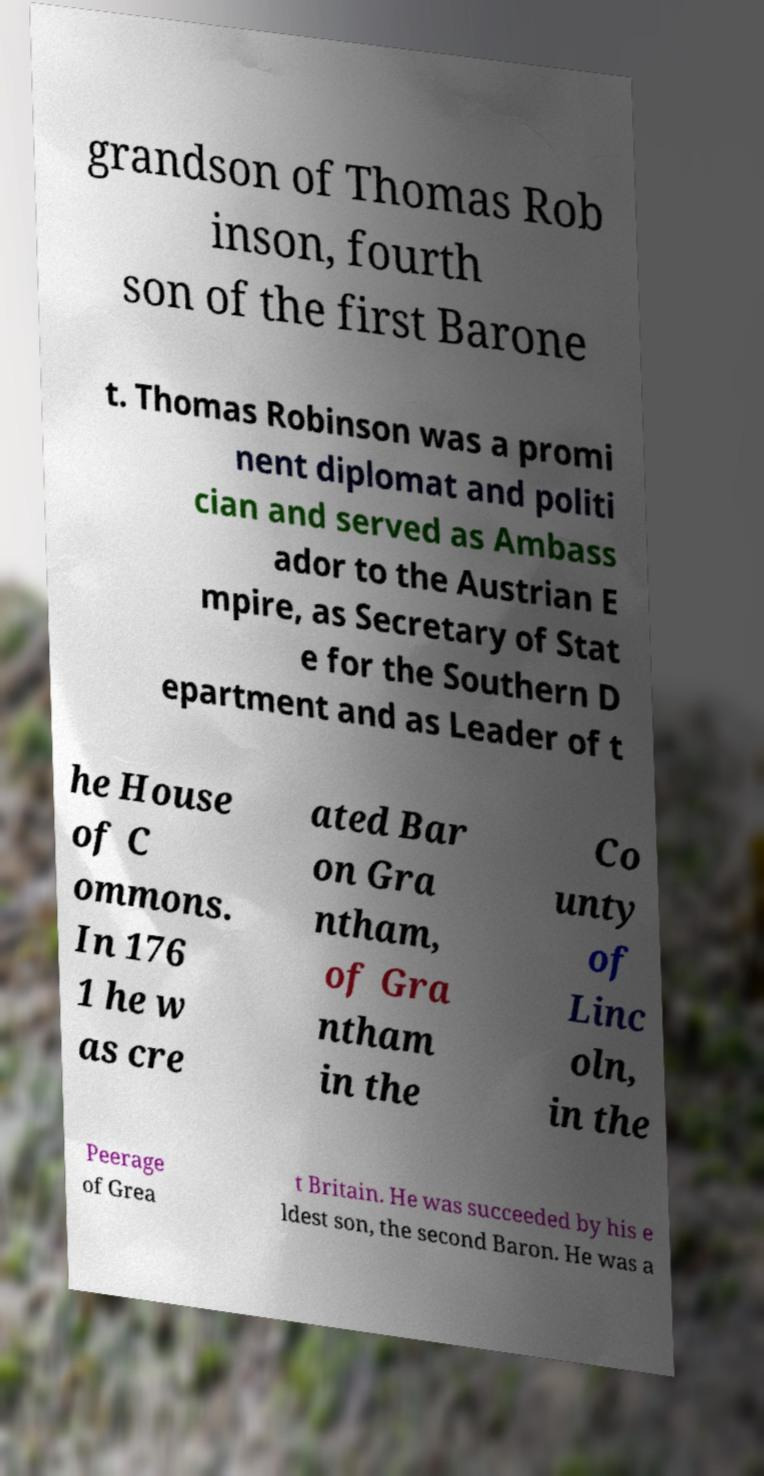Please identify and transcribe the text found in this image. grandson of Thomas Rob inson, fourth son of the first Barone t. Thomas Robinson was a promi nent diplomat and politi cian and served as Ambass ador to the Austrian E mpire, as Secretary of Stat e for the Southern D epartment and as Leader of t he House of C ommons. In 176 1 he w as cre ated Bar on Gra ntham, of Gra ntham in the Co unty of Linc oln, in the Peerage of Grea t Britain. He was succeeded by his e ldest son, the second Baron. He was a 